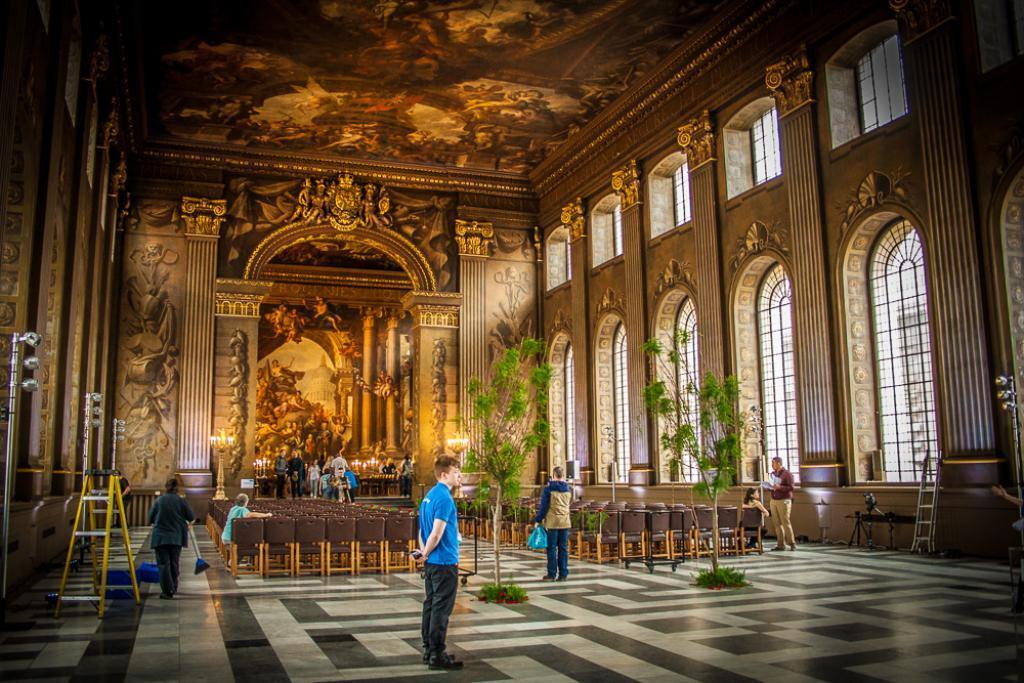Can you describe this image briefly? In this picture there is interior of a building and there is a person wearing blue shirt is standing and there is another person holding an object is standing and there are few chairs and persons on either sides of him and there are few persons,candles and some other objects in the background and there are few designs on the interior walls of the building. 